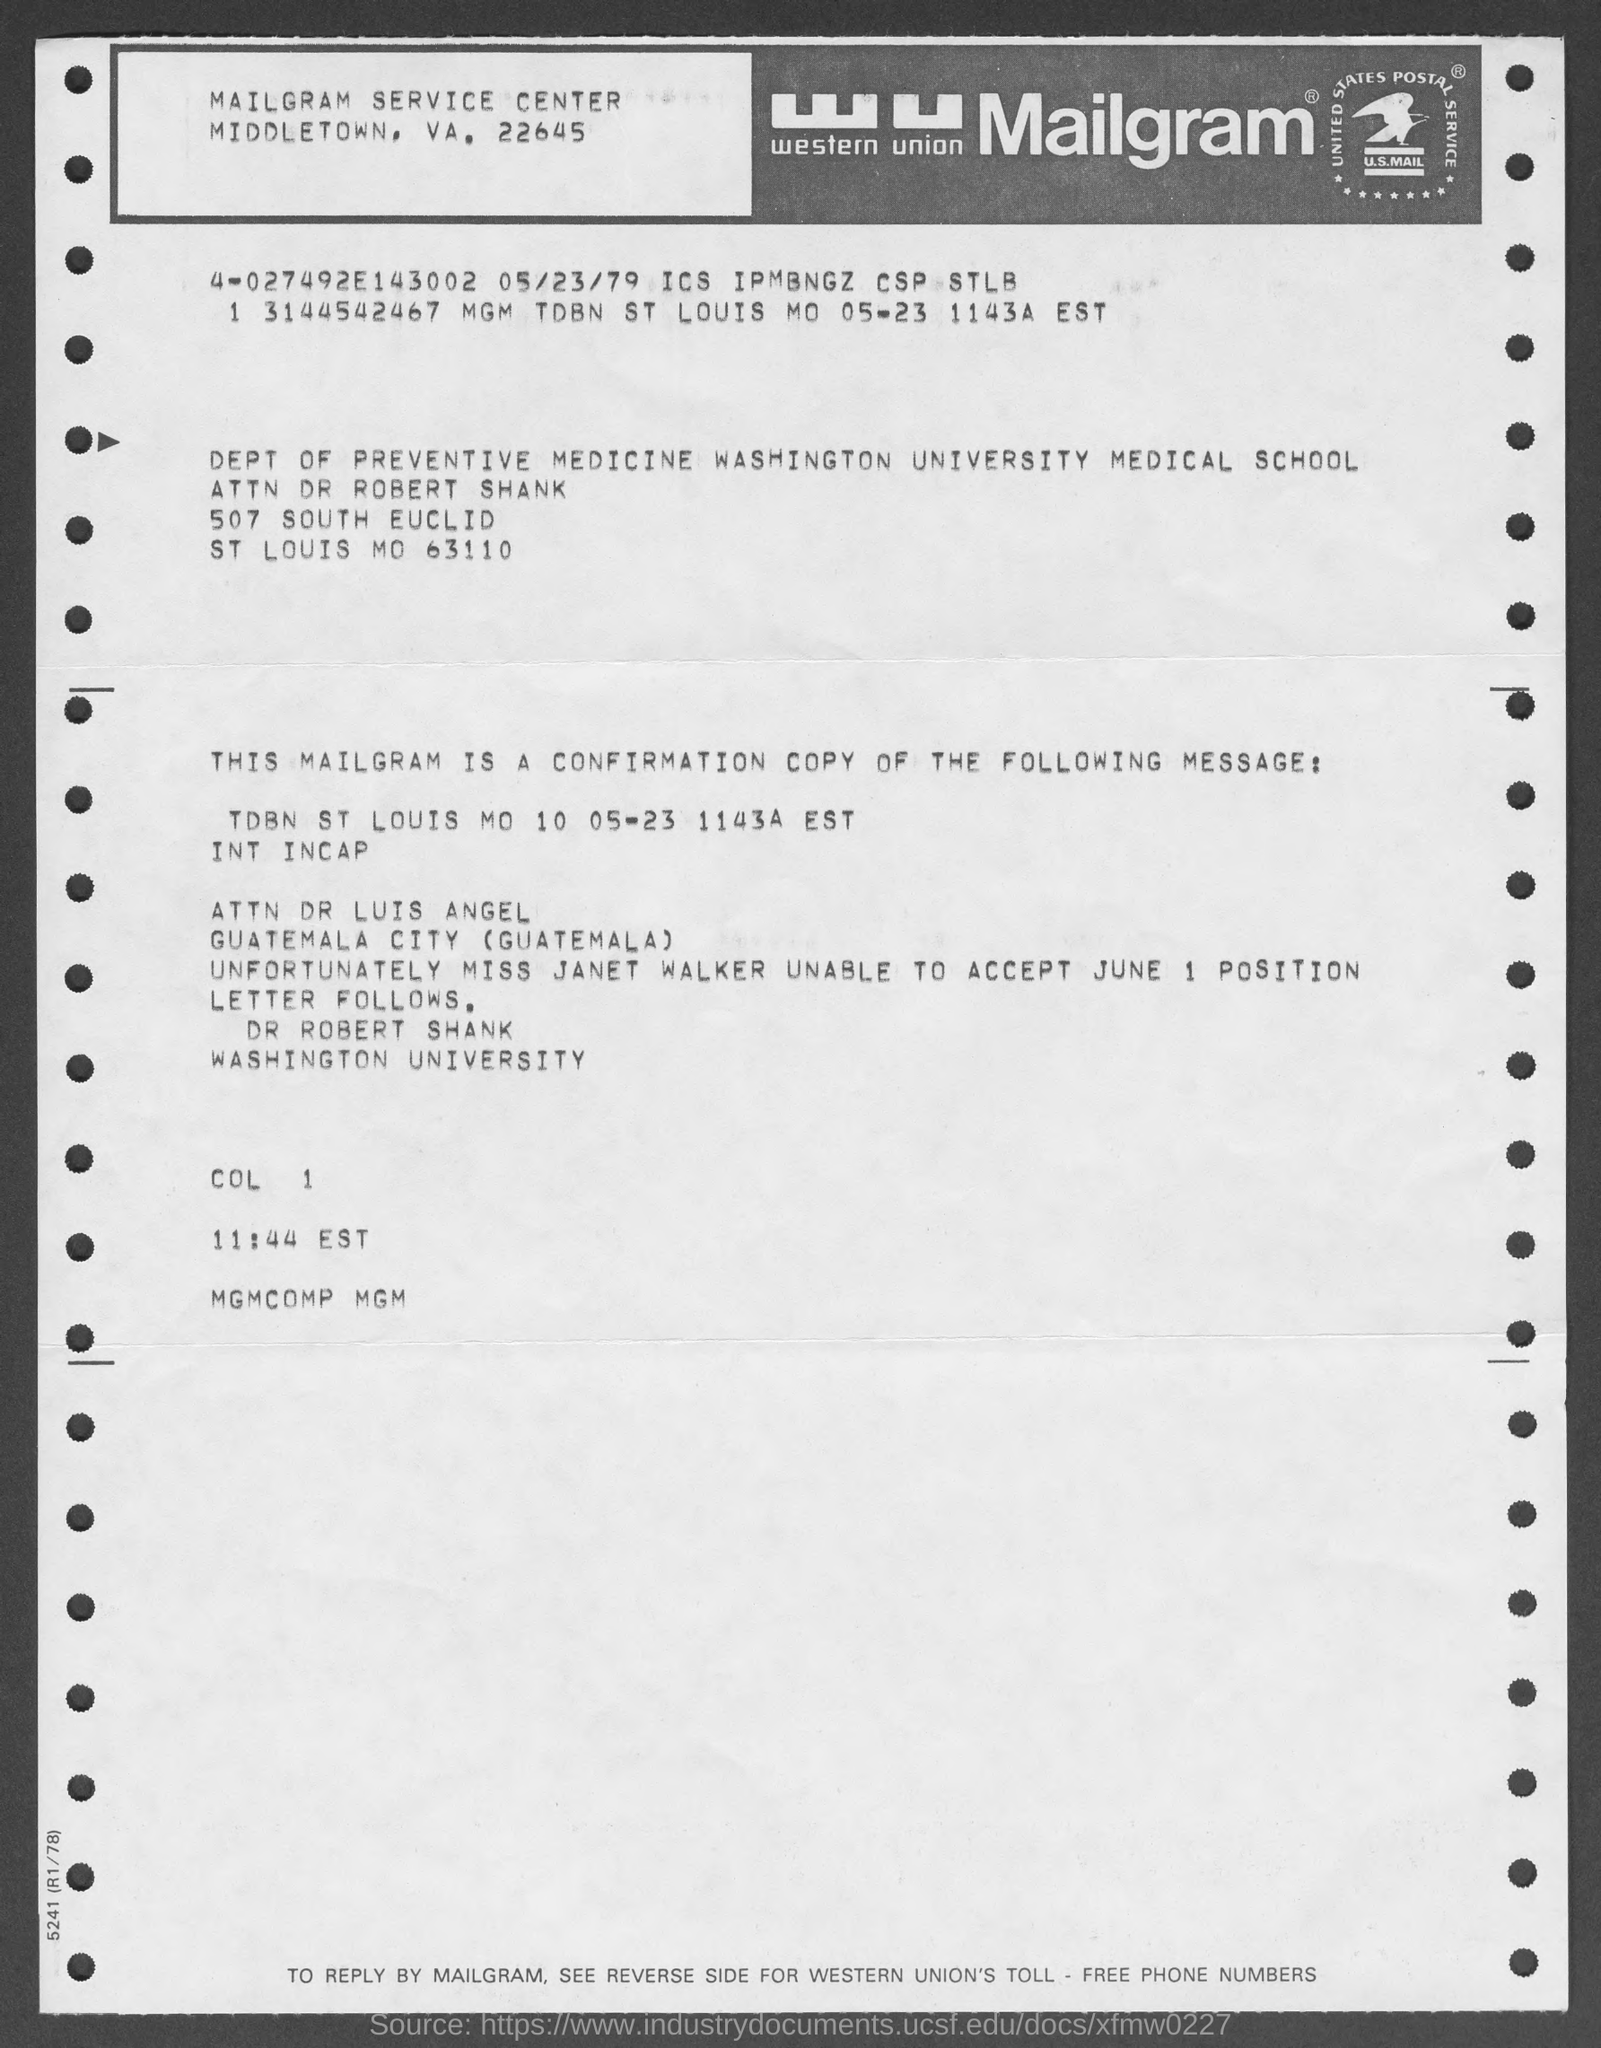Specify some key components in this picture. The text "U.S.MAIL" is written inside the logo. The location of the "Mailgram service center" is in MIDDLETOWN, VA, which can be found at 22645. The full form of "wu" is "Western Union. 